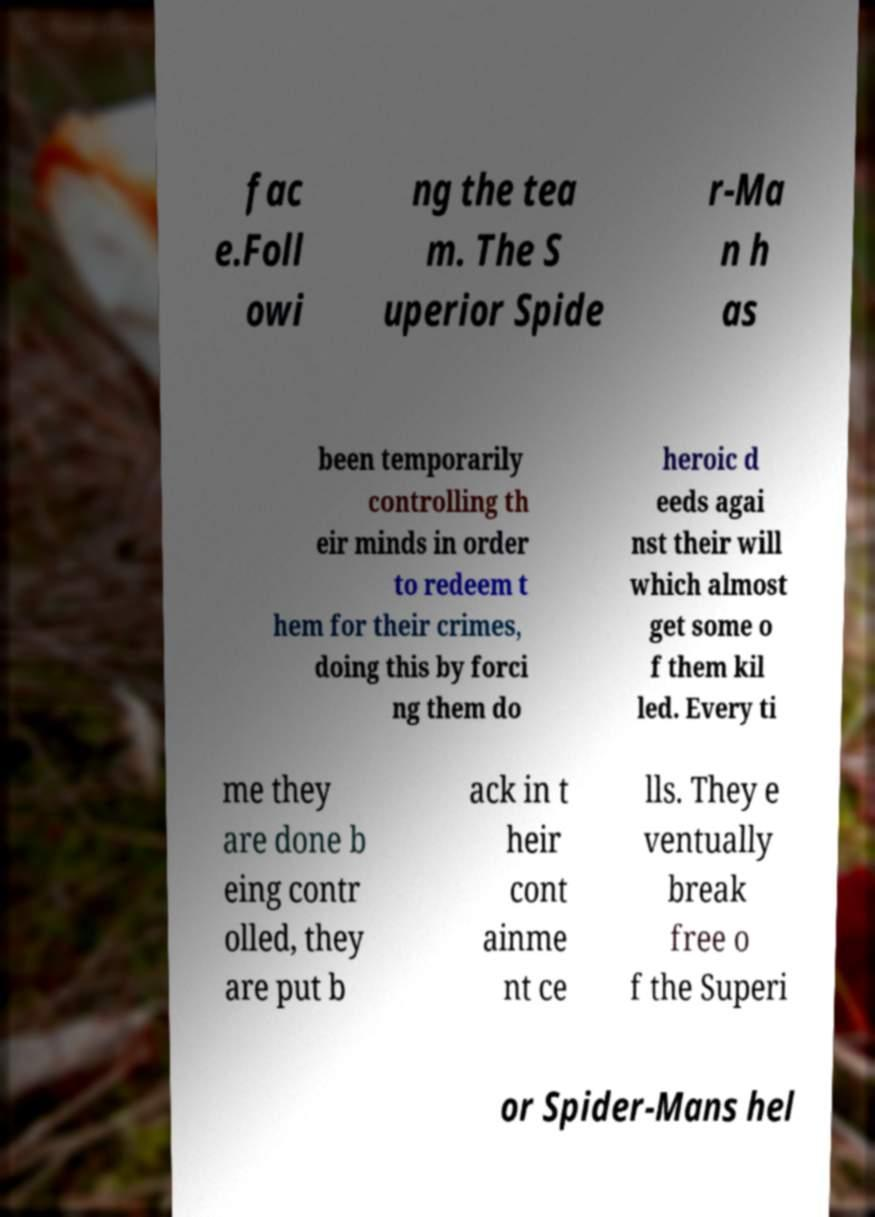Could you assist in decoding the text presented in this image and type it out clearly? fac e.Foll owi ng the tea m. The S uperior Spide r-Ma n h as been temporarily controlling th eir minds in order to redeem t hem for their crimes, doing this by forci ng them do heroic d eeds agai nst their will which almost get some o f them kil led. Every ti me they are done b eing contr olled, they are put b ack in t heir cont ainme nt ce lls. They e ventually break free o f the Superi or Spider-Mans hel 